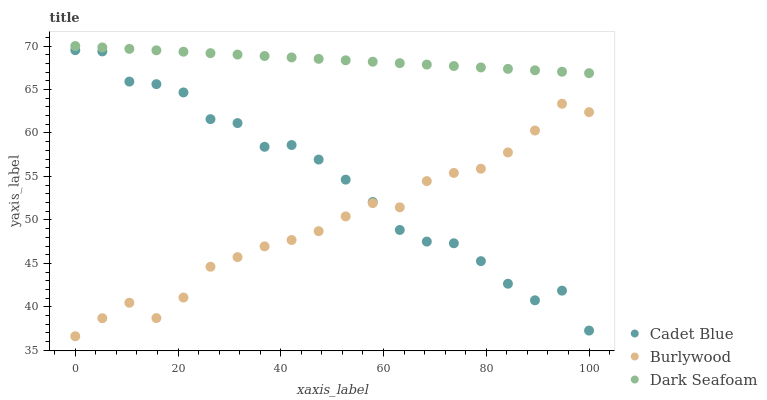Does Burlywood have the minimum area under the curve?
Answer yes or no. Yes. Does Dark Seafoam have the maximum area under the curve?
Answer yes or no. Yes. Does Cadet Blue have the minimum area under the curve?
Answer yes or no. No. Does Cadet Blue have the maximum area under the curve?
Answer yes or no. No. Is Dark Seafoam the smoothest?
Answer yes or no. Yes. Is Cadet Blue the roughest?
Answer yes or no. Yes. Is Cadet Blue the smoothest?
Answer yes or no. No. Is Dark Seafoam the roughest?
Answer yes or no. No. Does Burlywood have the lowest value?
Answer yes or no. Yes. Does Cadet Blue have the lowest value?
Answer yes or no. No. Does Dark Seafoam have the highest value?
Answer yes or no. Yes. Does Cadet Blue have the highest value?
Answer yes or no. No. Is Cadet Blue less than Dark Seafoam?
Answer yes or no. Yes. Is Dark Seafoam greater than Cadet Blue?
Answer yes or no. Yes. Does Burlywood intersect Cadet Blue?
Answer yes or no. Yes. Is Burlywood less than Cadet Blue?
Answer yes or no. No. Is Burlywood greater than Cadet Blue?
Answer yes or no. No. Does Cadet Blue intersect Dark Seafoam?
Answer yes or no. No. 